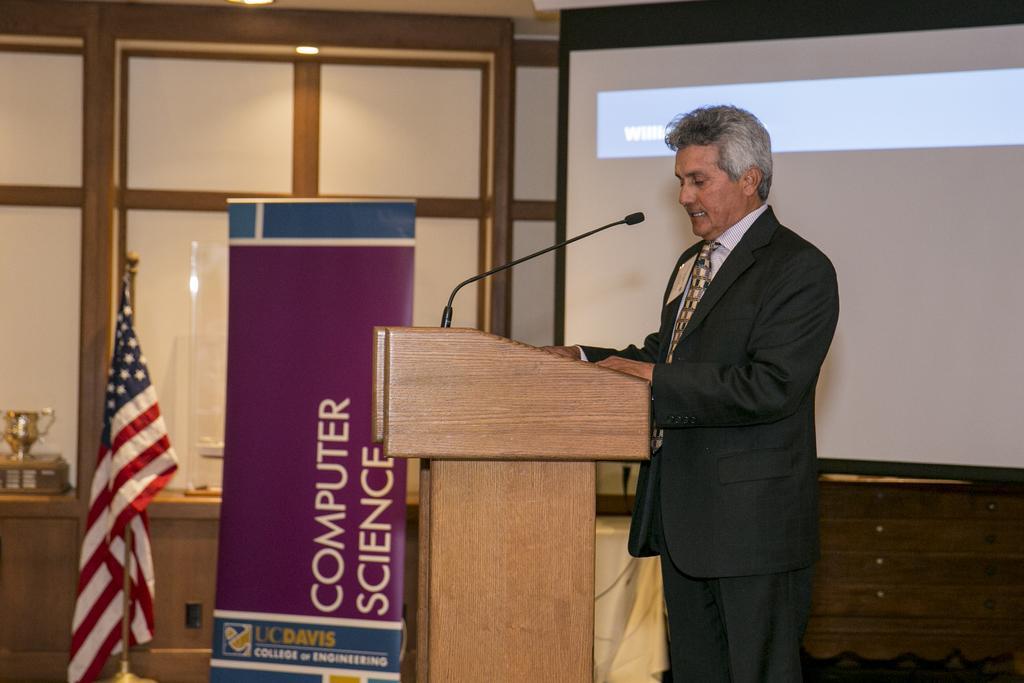Can you describe this image briefly? In this image we can see a person standing near to a podium with mic. In the back there is a banner, flag with a pole and a screen. Also there is a glass wall. Near to that there is a trophy on a wooden stand. 